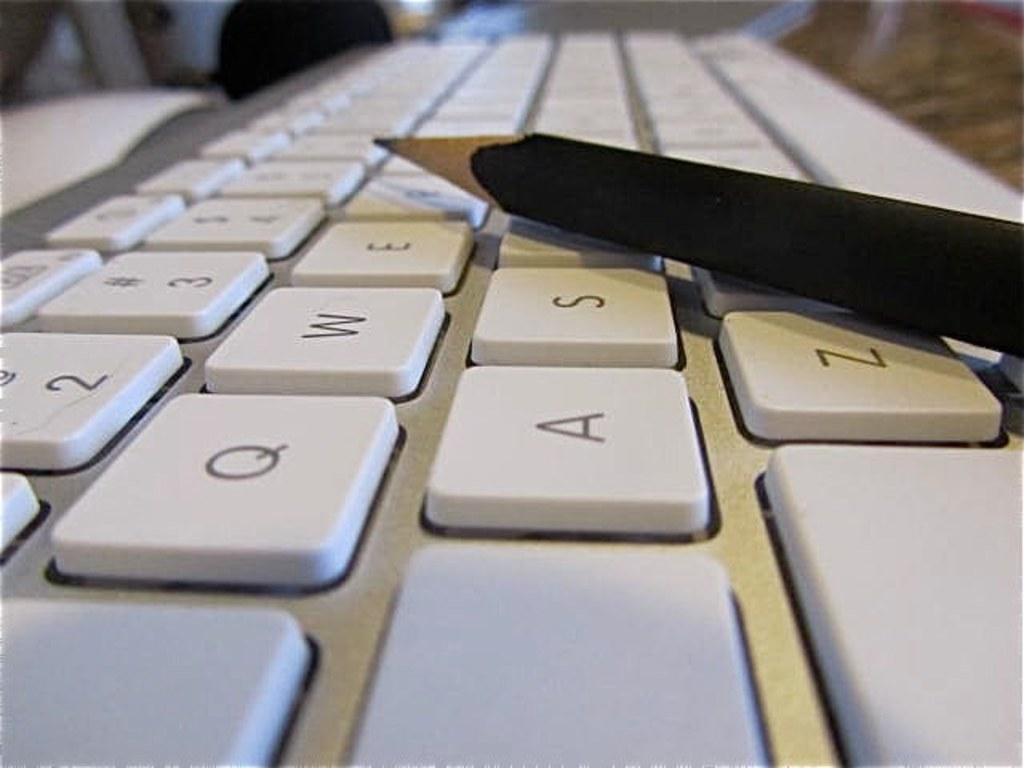<image>
Create a compact narrative representing the image presented. a close up of a white key board with letters Q and W 